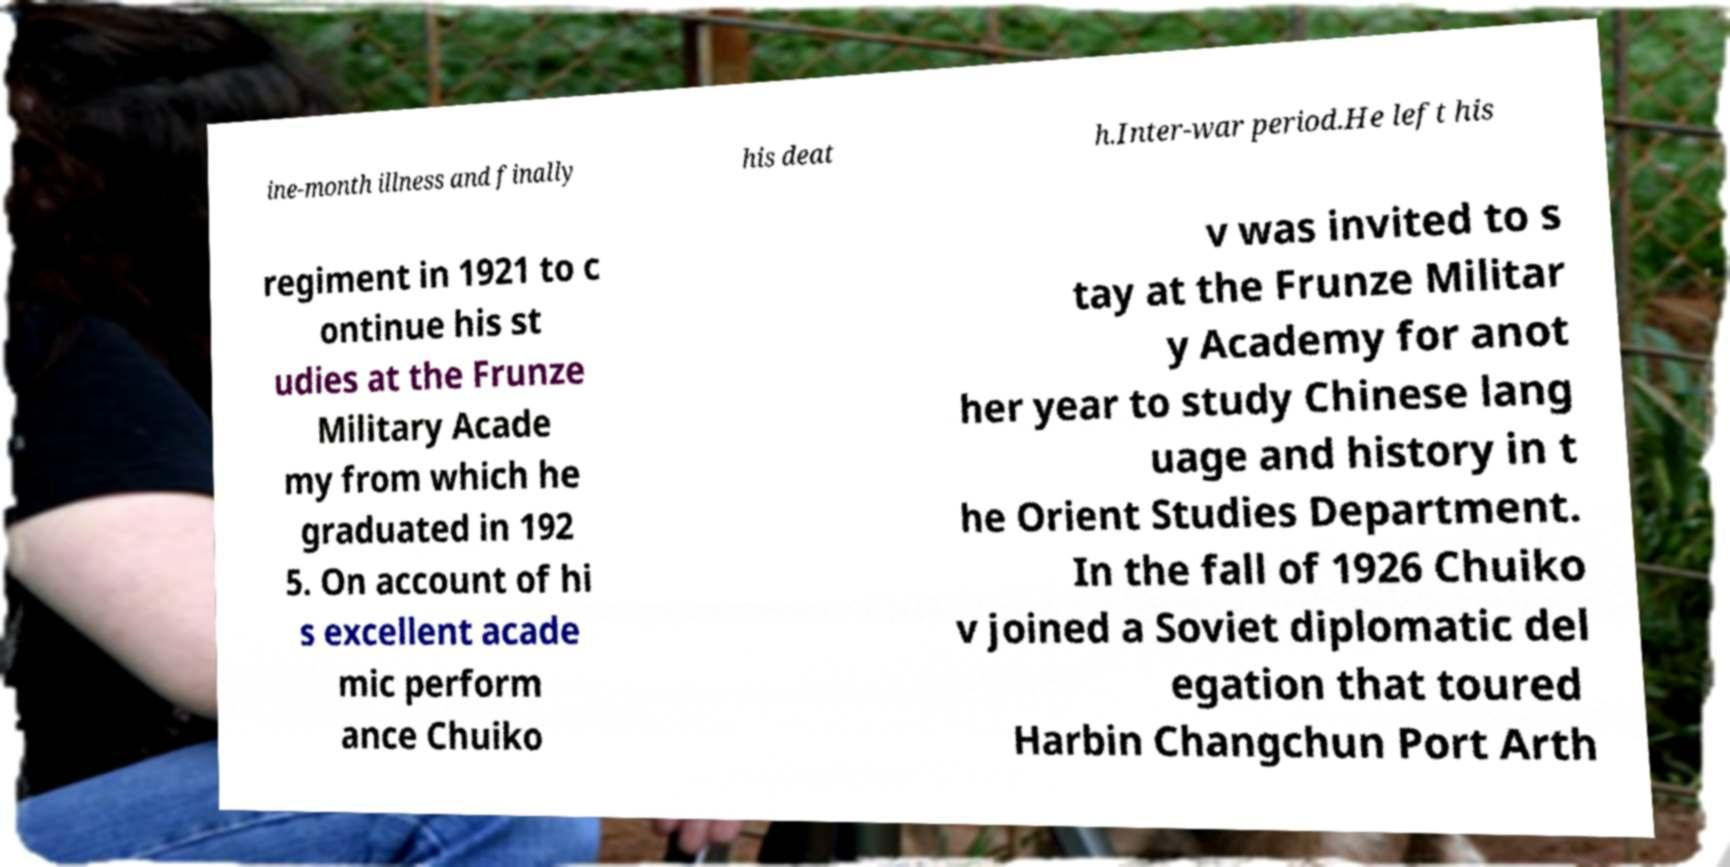Please read and relay the text visible in this image. What does it say? ine-month illness and finally his deat h.Inter-war period.He left his regiment in 1921 to c ontinue his st udies at the Frunze Military Acade my from which he graduated in 192 5. On account of hi s excellent acade mic perform ance Chuiko v was invited to s tay at the Frunze Militar y Academy for anot her year to study Chinese lang uage and history in t he Orient Studies Department. In the fall of 1926 Chuiko v joined a Soviet diplomatic del egation that toured Harbin Changchun Port Arth 